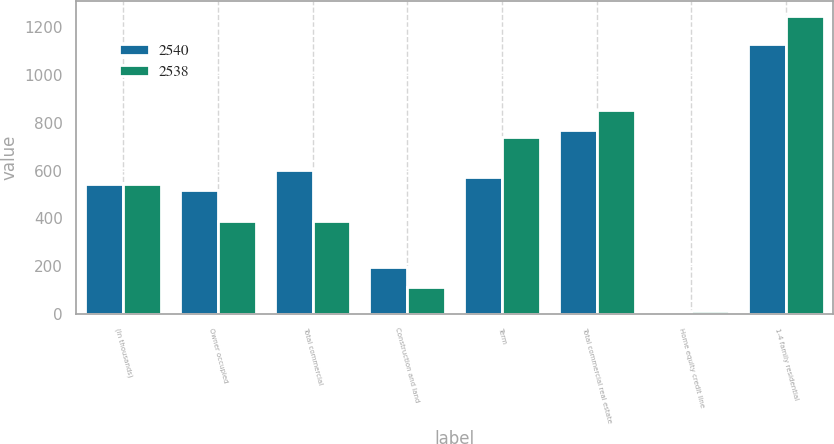Convert chart. <chart><loc_0><loc_0><loc_500><loc_500><stacked_bar_chart><ecel><fcel>(In thousands)<fcel>Owner occupied<fcel>Total commercial<fcel>Construction and land<fcel>Term<fcel>Total commercial real estate<fcel>Home equity credit line<fcel>1-4 family residential<nl><fcel>2540<fcel>546<fcel>519<fcel>603<fcel>197<fcel>573<fcel>770<fcel>5<fcel>1130<nl><fcel>2538<fcel>546<fcel>390<fcel>390<fcel>112<fcel>742<fcel>854<fcel>10<fcel>1248<nl></chart> 